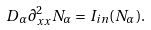Convert formula to latex. <formula><loc_0><loc_0><loc_500><loc_500>D _ { \alpha } \partial _ { x x } ^ { 2 } N _ { \alpha } = I _ { i n } ( N _ { \alpha } ) .</formula> 